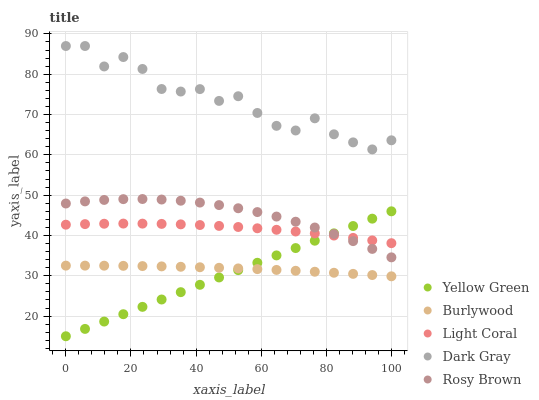Does Yellow Green have the minimum area under the curve?
Answer yes or no. Yes. Does Dark Gray have the maximum area under the curve?
Answer yes or no. Yes. Does Light Coral have the minimum area under the curve?
Answer yes or no. No. Does Light Coral have the maximum area under the curve?
Answer yes or no. No. Is Yellow Green the smoothest?
Answer yes or no. Yes. Is Dark Gray the roughest?
Answer yes or no. Yes. Is Light Coral the smoothest?
Answer yes or no. No. Is Light Coral the roughest?
Answer yes or no. No. Does Yellow Green have the lowest value?
Answer yes or no. Yes. Does Light Coral have the lowest value?
Answer yes or no. No. Does Dark Gray have the highest value?
Answer yes or no. Yes. Does Light Coral have the highest value?
Answer yes or no. No. Is Yellow Green less than Dark Gray?
Answer yes or no. Yes. Is Rosy Brown greater than Burlywood?
Answer yes or no. Yes. Does Rosy Brown intersect Light Coral?
Answer yes or no. Yes. Is Rosy Brown less than Light Coral?
Answer yes or no. No. Is Rosy Brown greater than Light Coral?
Answer yes or no. No. Does Yellow Green intersect Dark Gray?
Answer yes or no. No. 